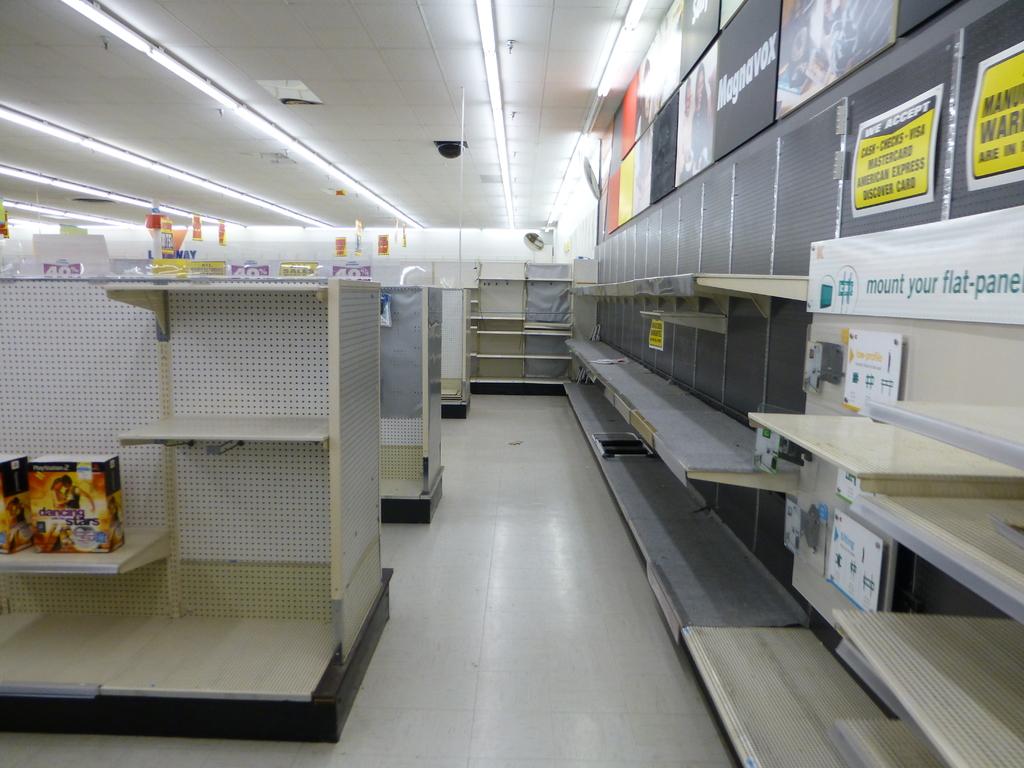What is the first thing the store accepts?
Your answer should be compact. Cash. On the right of this image, what should you do to your flat panel/?
Provide a short and direct response. Mount. 